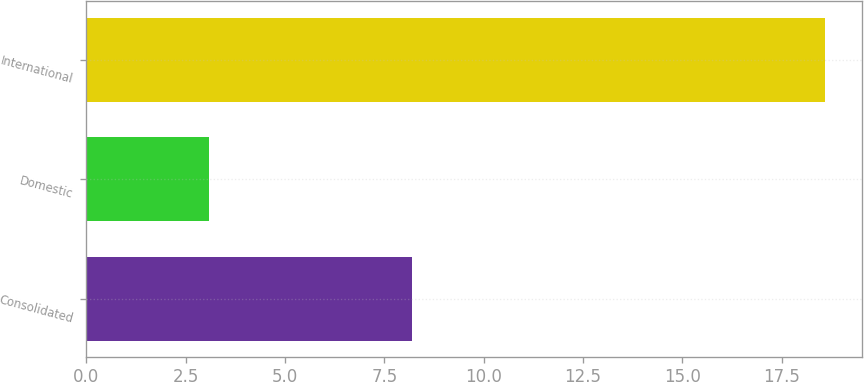Convert chart. <chart><loc_0><loc_0><loc_500><loc_500><bar_chart><fcel>Consolidated<fcel>Domestic<fcel>International<nl><fcel>8.2<fcel>3.1<fcel>18.6<nl></chart> 